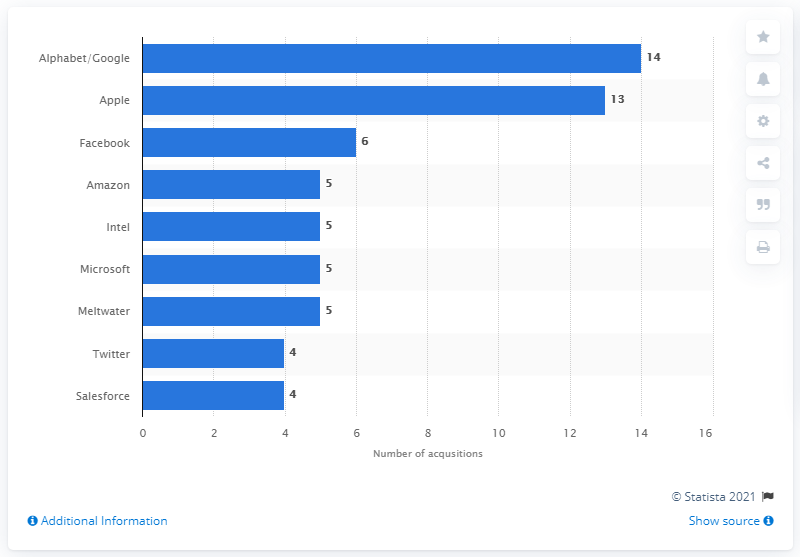Identify some key points in this picture. Google acquired 14 artificial intelligence startups between 2010 and June 2018. 